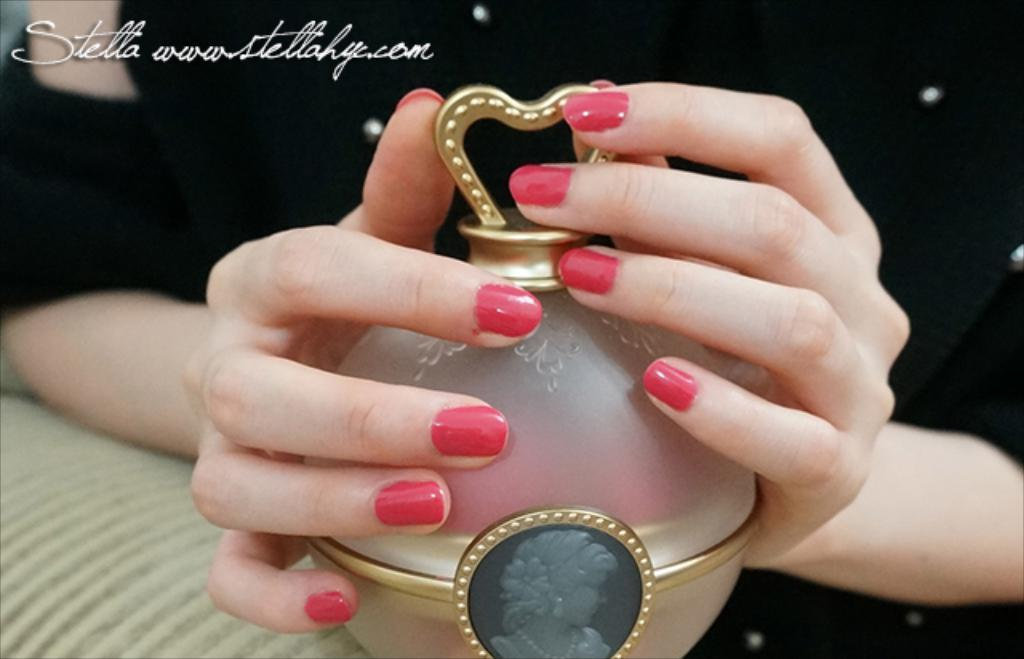<image>
Write a terse but informative summary of the picture. a perfume bottle next to a name that says Stella 